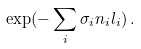Convert formula to latex. <formula><loc_0><loc_0><loc_500><loc_500>\exp ( - \sum _ { i } \sigma _ { i } n _ { i } l _ { i } ) \, .</formula> 